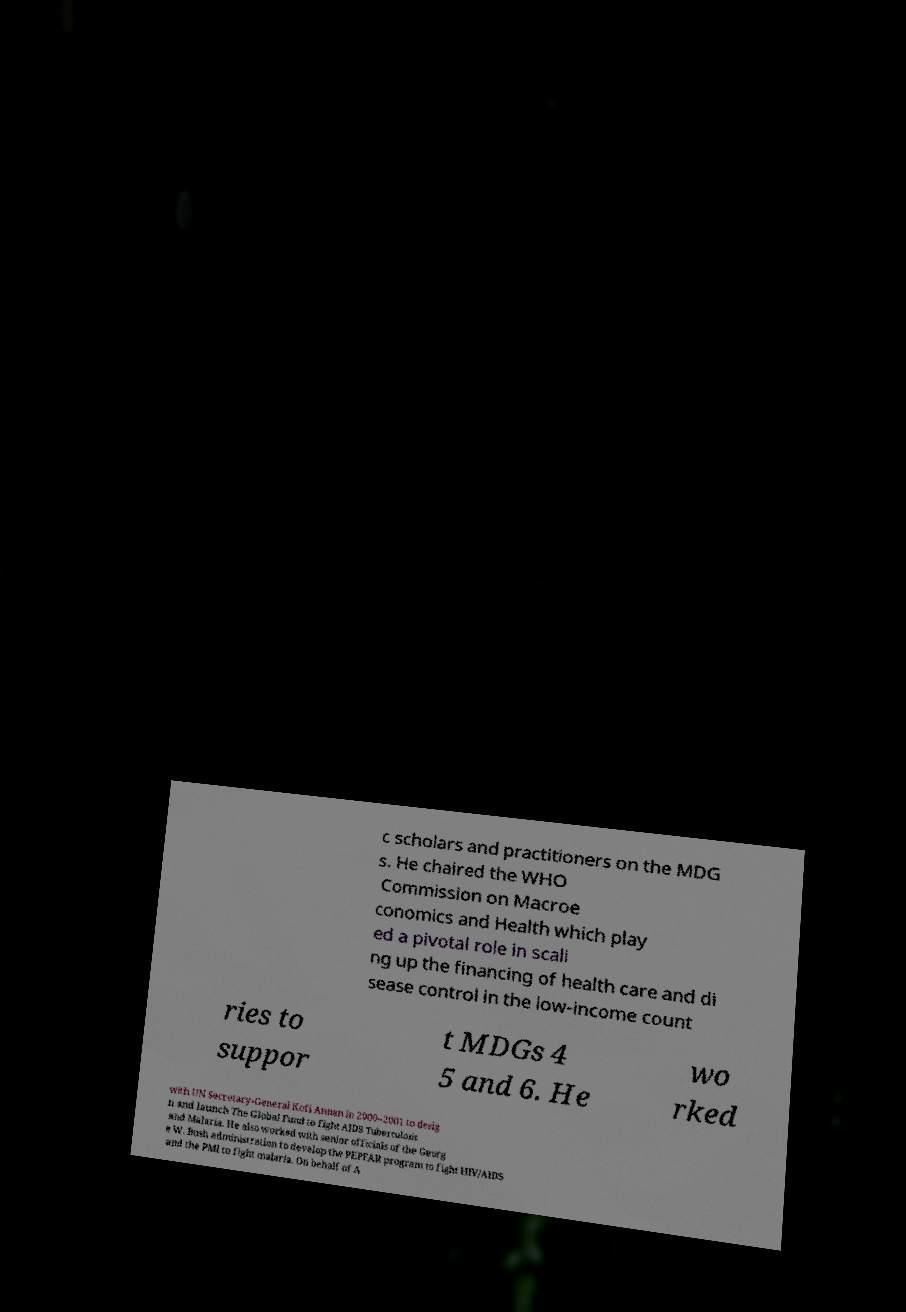Please read and relay the text visible in this image. What does it say? c scholars and practitioners on the MDG s. He chaired the WHO Commission on Macroe conomics and Health which play ed a pivotal role in scali ng up the financing of health care and di sease control in the low-income count ries to suppor t MDGs 4 5 and 6. He wo rked with UN Secretary-General Kofi Annan in 2000–2001 to desig n and launch The Global Fund to Fight AIDS Tuberculosis and Malaria. He also worked with senior officials of the Georg e W. Bush administration to develop the PEPFAR program to fight HIV/AIDS and the PMI to fight malaria. On behalf of A 